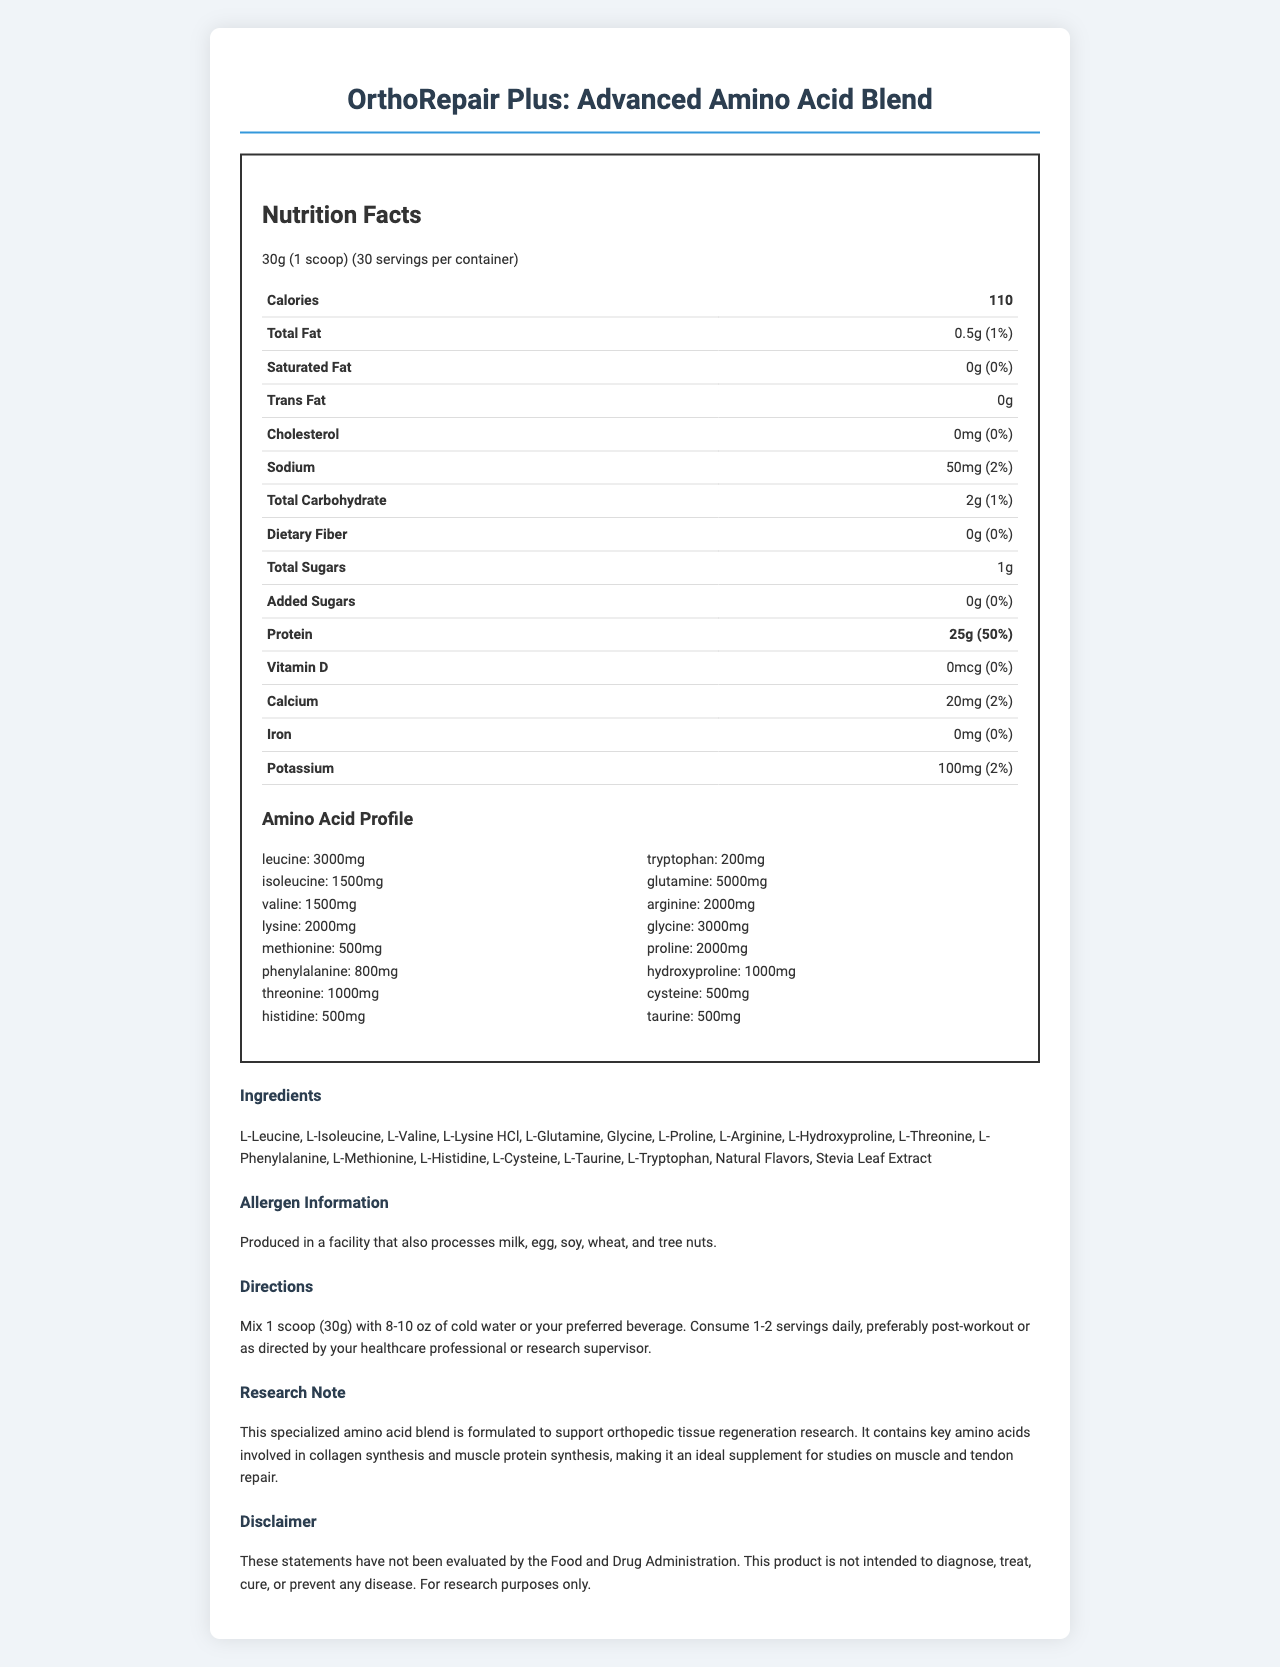what is the serving size for OrthoRepair Plus? The serving size listed for OrthoRepair Plus is 30 grams, which is equivalent to 1 scoop.
Answer: 30g (1 scoop) how many calories are in one serving of OrthoRepair Plus? The document states that each serving contains 110 calories.
Answer: 110 what is the protein content per serving and its daily value percentage? The amount of protein per serving is 25 grams, which is 50% of the daily value.
Answer: 25g, 50% how much sodium is in each serving and what is its daily value percentage? Each serving contains 50 milligrams of sodium, which is 2% of the daily value.
Answer: 50mg, 2% which three amino acids have the highest content in OrthoRepair Plus? The top three amino acids by content are Glutamine (5000mg), Glycine (3000mg), and Leucine (3000mg).
Answer: Glutamine, Glycine, Leucine how many servings are there per container? The document mentions that there are 30 servings per container.
Answer: 30 what is the cholesterol content in OrthoRepair Plus? A. 0mg B. 5mg C. 10mg D. 20mg The cholesterol content is listed as 0mg.
Answer: A which of the following amino acids is present in the smallest amount in OrthoRepair Plus? A. Threonine B. Hydroxyproline C. Tryptophan D. Phenylalanine Tryptophan is present in the smallest amount, with 200mg.
Answer: C does OrthoRepair Plus contain any added sugars? The document lists the amount of added sugars as 0g, indicating there are no added sugars.
Answer: No was this product evaluated by the Food and Drug Administration (FDA)? The disclaimer states that these statements have not been evaluated by the FDA.
Answer: No summarize the main purpose of OrthoRepair Plus. The document explains that OrthoRepair Plus is specially formulated to aid in orthopedic tissue regeneration by providing essential amino acids for collagen and muscle protein synthesis, and it is intended to be used in research settings.
Answer: OrthoRepair Plus is an advanced amino acid blend designed to support orthopedic tissue regeneration research. It provides key amino acids involved in collagen and muscle protein synthesis, making it suitable for muscle and tendon repair studies. what is the address of the production facility? The document does not provide any details about the address of the production facility.
Answer: Not enough information 